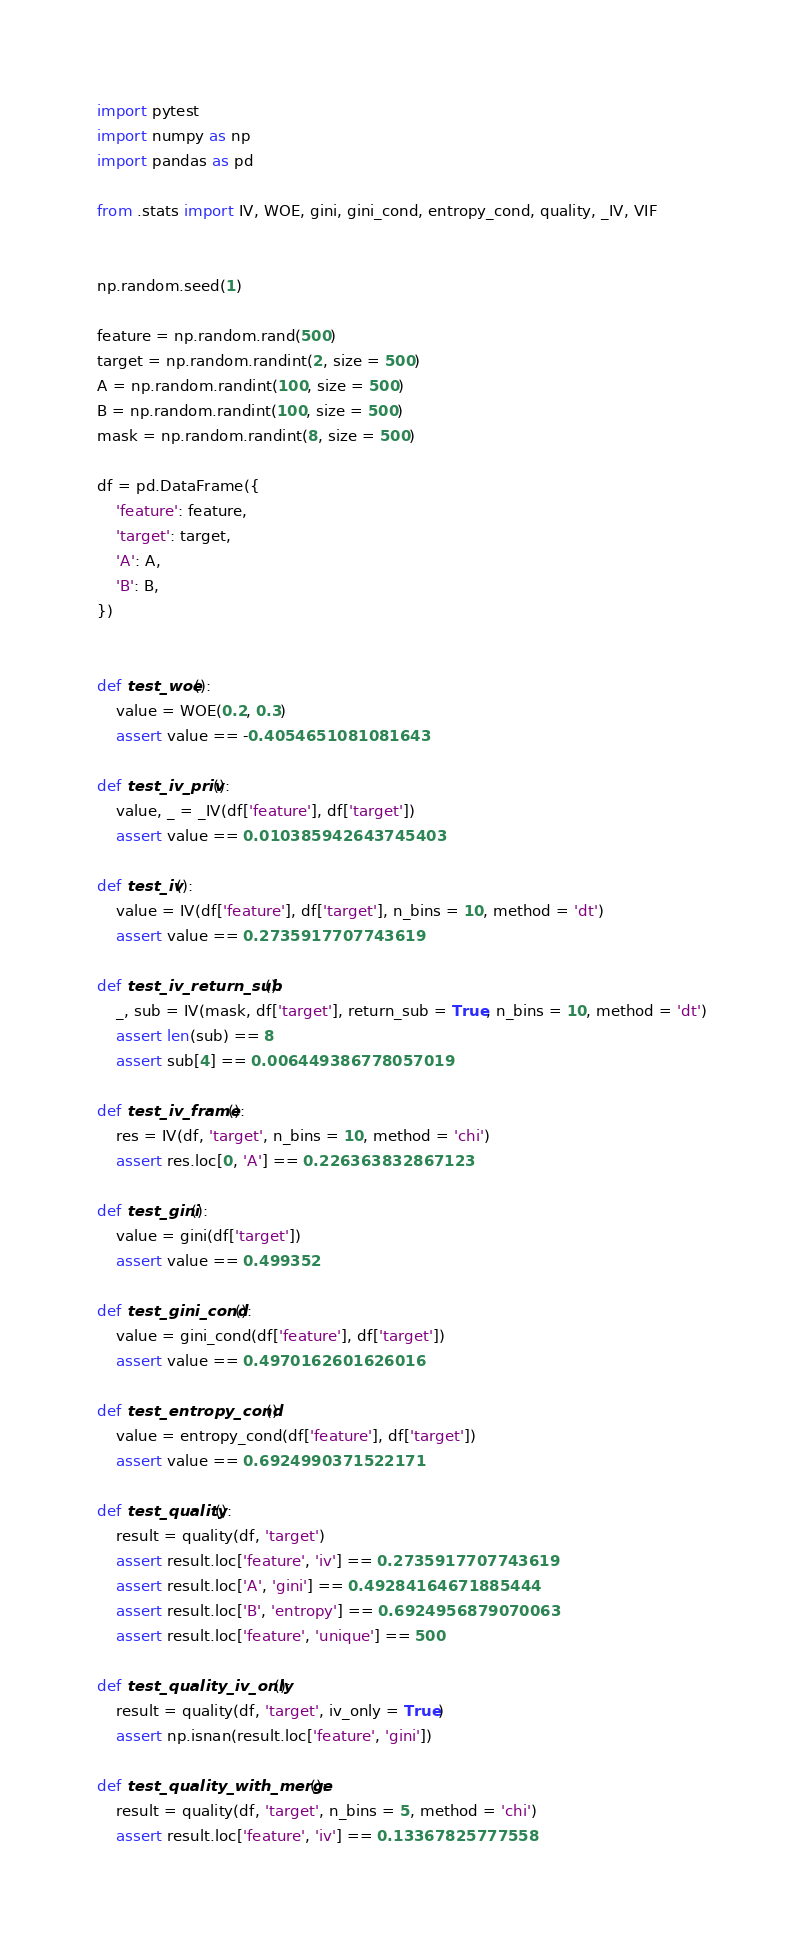Convert code to text. <code><loc_0><loc_0><loc_500><loc_500><_Python_>import pytest
import numpy as np
import pandas as pd

from .stats import IV, WOE, gini, gini_cond, entropy_cond, quality, _IV, VIF


np.random.seed(1)

feature = np.random.rand(500)
target = np.random.randint(2, size = 500)
A = np.random.randint(100, size = 500)
B = np.random.randint(100, size = 500)
mask = np.random.randint(8, size = 500)

df = pd.DataFrame({
    'feature': feature,
    'target': target,
    'A': A,
    'B': B,
})


def test_woe():
    value = WOE(0.2, 0.3)
    assert value == -0.4054651081081643

def test_iv_priv():
    value, _ = _IV(df['feature'], df['target'])
    assert value == 0.010385942643745403

def test_iv():
    value = IV(df['feature'], df['target'], n_bins = 10, method = 'dt')
    assert value == 0.2735917707743619

def test_iv_return_sub():
    _, sub = IV(mask, df['target'], return_sub = True, n_bins = 10, method = 'dt')
    assert len(sub) == 8
    assert sub[4] == 0.006449386778057019

def test_iv_frame():
    res = IV(df, 'target', n_bins = 10, method = 'chi')
    assert res.loc[0, 'A'] == 0.226363832867123

def test_gini():
    value = gini(df['target'])
    assert value == 0.499352

def test_gini_cond():
    value = gini_cond(df['feature'], df['target'])
    assert value == 0.4970162601626016

def test_entropy_cond():
    value = entropy_cond(df['feature'], df['target'])
    assert value == 0.6924990371522171

def test_quality():
    result = quality(df, 'target')
    assert result.loc['feature', 'iv'] == 0.2735917707743619
    assert result.loc['A', 'gini'] == 0.49284164671885444
    assert result.loc['B', 'entropy'] == 0.6924956879070063
    assert result.loc['feature', 'unique'] == 500

def test_quality_iv_only():
    result = quality(df, 'target', iv_only = True)
    assert np.isnan(result.loc['feature', 'gini'])

def test_quality_with_merge():
    result = quality(df, 'target', n_bins = 5, method = 'chi')
    assert result.loc['feature', 'iv'] == 0.13367825777558
</code> 